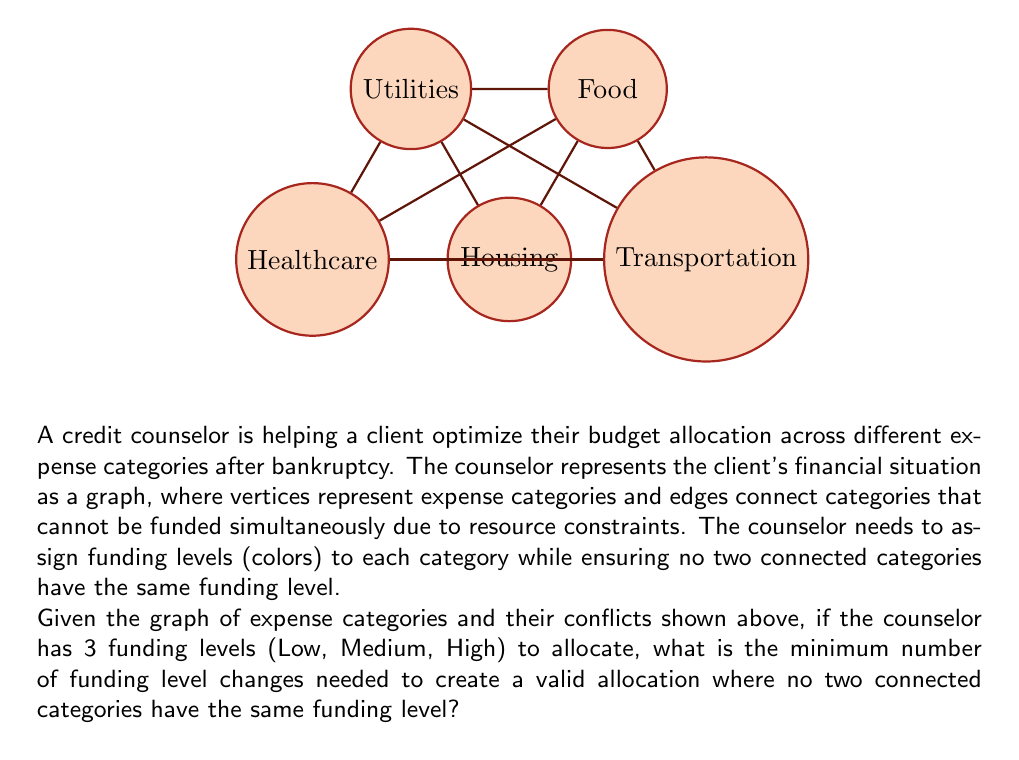Teach me how to tackle this problem. To solve this problem, we need to use the concept of graph coloring, where each color represents a funding level. The goal is to find the chromatic number of the graph, which is the minimum number of colors needed to color the vertices such that no two adjacent vertices have the same color.

Step 1: Analyze the graph structure
The given graph is a complete graph K5, where every vertex is connected to every other vertex. This is the most challenging case for graph coloring.

Step 2: Determine the chromatic number
For a complete graph Kn, the chromatic number is always n. In this case, with 5 vertices, the chromatic number is 5.

Step 3: Compare with available funding levels
We have 3 funding levels (colors) available, but we need 5 to properly color the graph.

Step 4: Calculate the minimum number of funding level changes
To use only 3 colors instead of 5, we need to change the color of at least 2 vertices. This is because:
- We start with 3 colors for 3 vertices
- For the 4th vertex, we need to reuse a color, requiring 1 change
- For the 5th vertex, we need to reuse another color, requiring 1 more change

Therefore, the minimum number of funding level changes needed is 2.

Step 5: Verify the solution
We can confirm this by attempting to color the graph with 3 colors:
- Assign Low to Housing
- Assign Medium to Transportation
- Assign High to Food
- Change Housing to High (1st change)
- Change Transportation to Low (2nd change)

This coloring ensures no two connected categories have the same funding level.
Answer: 2 funding level changes 